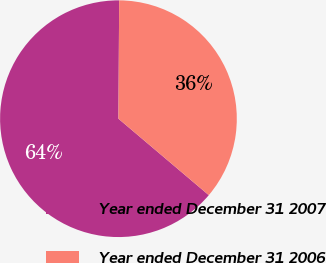Convert chart. <chart><loc_0><loc_0><loc_500><loc_500><pie_chart><fcel>Year ended December 31 2007<fcel>Year ended December 31 2006<nl><fcel>63.92%<fcel>36.08%<nl></chart> 